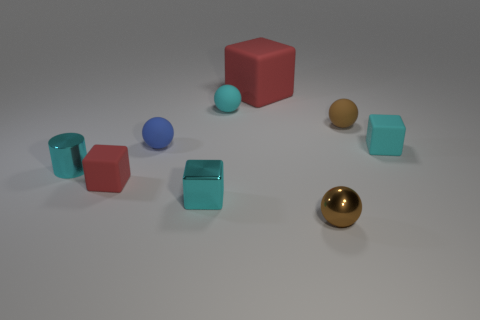Add 1 brown rubber spheres. How many objects exist? 10 Subtract all cylinders. How many objects are left? 8 Add 5 big red matte things. How many big red matte things exist? 6 Subtract 0 brown cubes. How many objects are left? 9 Subtract all large rubber objects. Subtract all cyan shiny blocks. How many objects are left? 7 Add 5 red rubber blocks. How many red rubber blocks are left? 7 